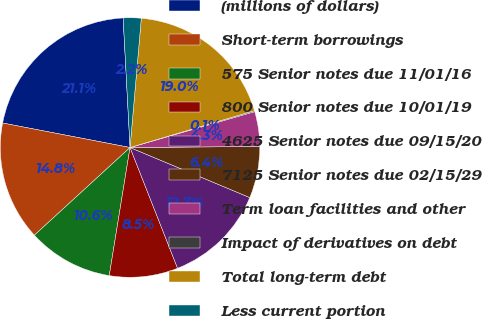Convert chart. <chart><loc_0><loc_0><loc_500><loc_500><pie_chart><fcel>(millions of dollars)<fcel>Short-term borrowings<fcel>575 Senior notes due 11/01/16<fcel>800 Senior notes due 10/01/19<fcel>4625 Senior notes due 09/15/20<fcel>7125 Senior notes due 02/15/29<fcel>Term loan facilities and other<fcel>Impact of derivatives on debt<fcel>Total long-term debt<fcel>Less current portion<nl><fcel>21.13%<fcel>14.83%<fcel>10.63%<fcel>8.53%<fcel>12.73%<fcel>6.43%<fcel>4.33%<fcel>0.13%<fcel>19.03%<fcel>2.23%<nl></chart> 